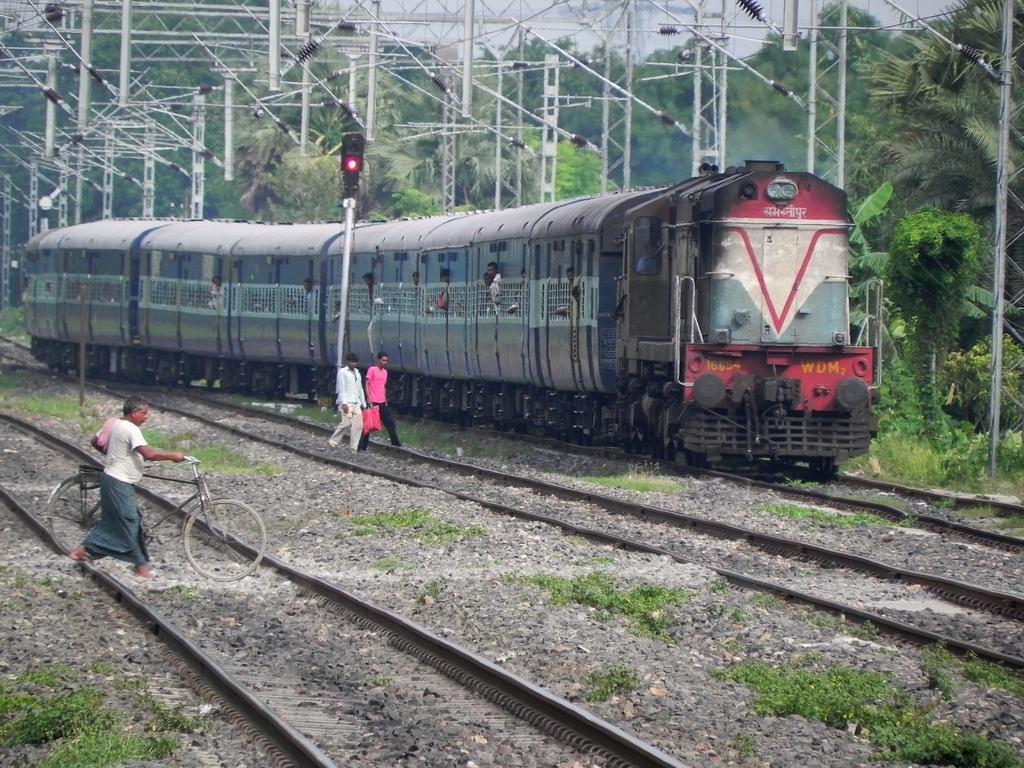How would you summarize this image in a sentence or two? In this picture there is a train on the track. It is in blue in color. Beside it, there is a signal and two men. One of the man is wearing a pink t shirt and another man is wearing a white shirt and holding a cover. Towards the bottom left, there is a person holding a bicycle. On the top, there are rods and trees. 